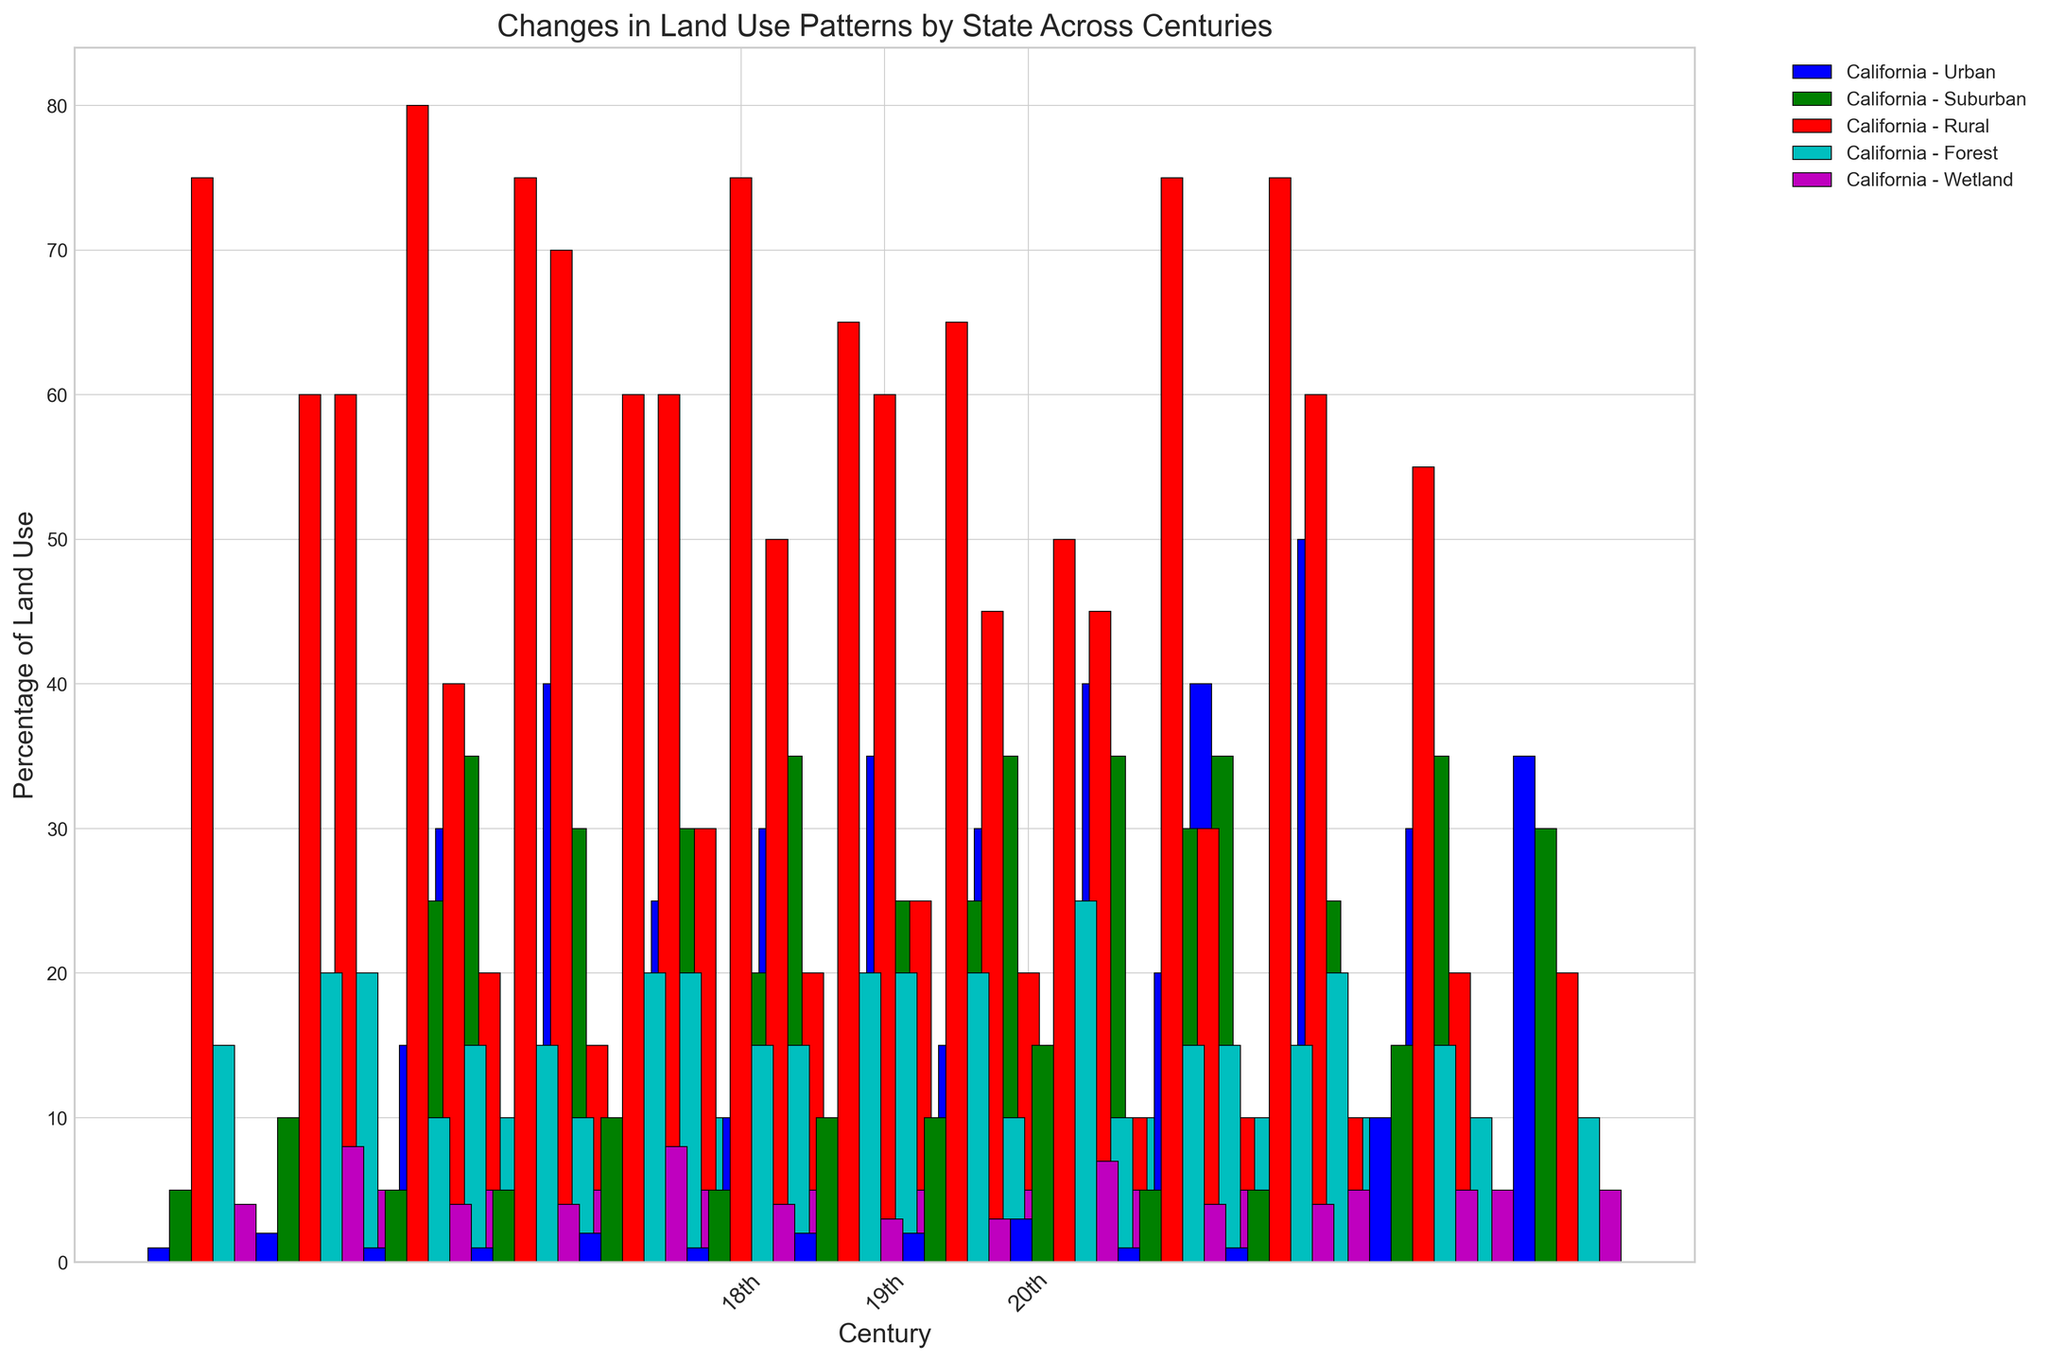Which state had the highest percentage of urban land use in the 20th century? To find the answer, look at the heights of the 'Urban' bars for all states in the 20th-century groups and identify the tallest bar.
Answer: Massachusetts How did the percentage of forest land in California change from the 18th to the 20th century? Observe the heights of the 'Forest' bars for California across the 18th, 19th, and 20th centuries and note the changes in values.
Answer: Decreased Between Ohio and Illinois, which state had a higher percentage of rural land in the 19th century? Compare the heights of the 'Rural' bars for Ohio and Illinois in the 19th-century group and see which is taller.
Answer: Ohio In the 20th century, which land use category had the least percentage in Texas? Look at the heights of the bars for each category in Texas in the 20th-century group and find the shortest one.
Answer: Wetland What is the average percentage of suburban land use in New York across the centuries shown? Sum the heights of the 'Suburban' bars for New York across the 18th, 19th, and 20th centuries and then divide by 3.
Answer: 21.67 By how many percentage points did urban land use increase in Georgia from the 19th to the 20th century? Subtract the value of the 'Urban' bar in the 19th-century group from the value in the 20th-century group for Georgia.
Answer: 25 Which state had a higher percentage of wetland in the 18th century, Massachusetts or Pennsylvania? Compare the heights of the 'Wetland' bars for Massachusetts and Pennsylvania in the 18th-century group.
Answer: Massachusetts What is the total percentage of land used for suburban purposes in the states of California and Florida in the 20th century? Add the 'Suburban' bar heights for California and Florida in the 20th-century group together.
Answer: 70 How does the percentage of forest land in Florida in the 19th century compare to that in Texas in the same century? Compare the heights of the 'Forest' bars for Florida and Texas in the 19th-century group.
Answer: Equal What is the sum of the changes in rural land use percentage for Ohio across the three centuries? Calculate the differences in heights of the 'Rural' bars for Ohio between each consecutive century (18th to 19th, and 19th to 20th), then sum them up (60-50 = -10, 50-25 = -25) and (Total change = -10 + -25 = -35).
Answer: -35 